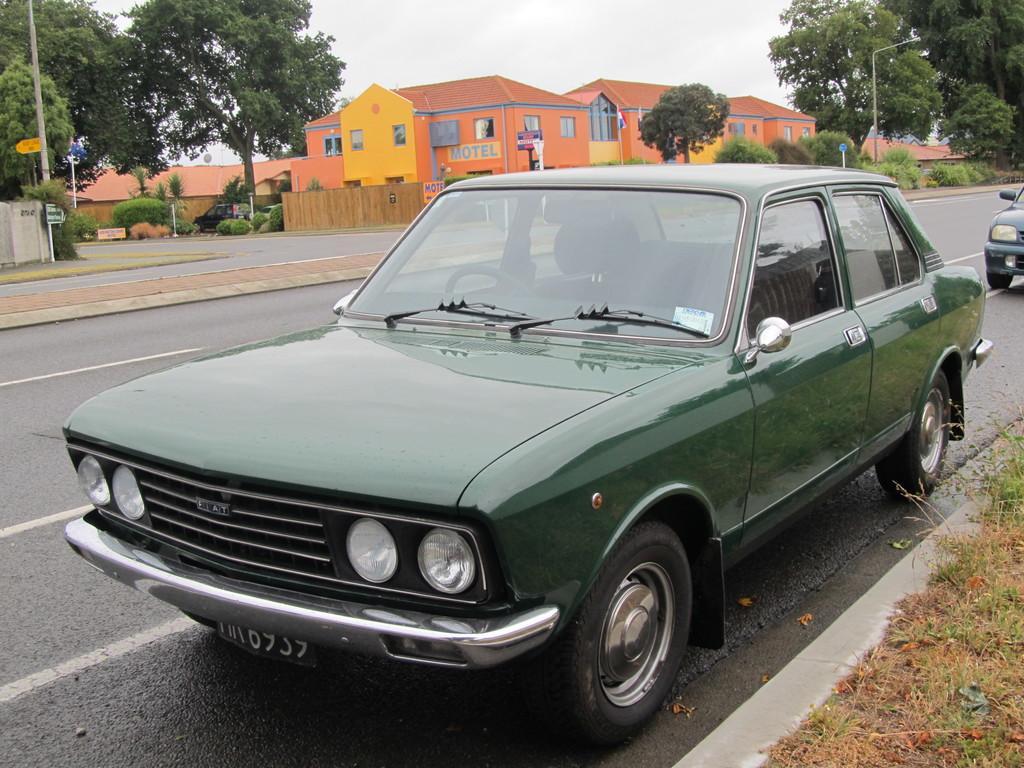In one or two sentences, can you explain what this image depicts? We can see cars on the road and we can see grass. In the background we can see houses,trees,plants,poles and sky. 